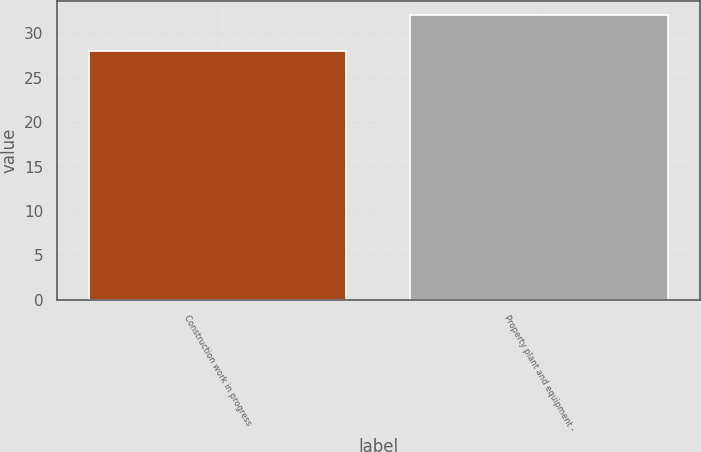<chart> <loc_0><loc_0><loc_500><loc_500><bar_chart><fcel>Construction work in progress<fcel>Property plant and equipment -<nl><fcel>28<fcel>32<nl></chart> 